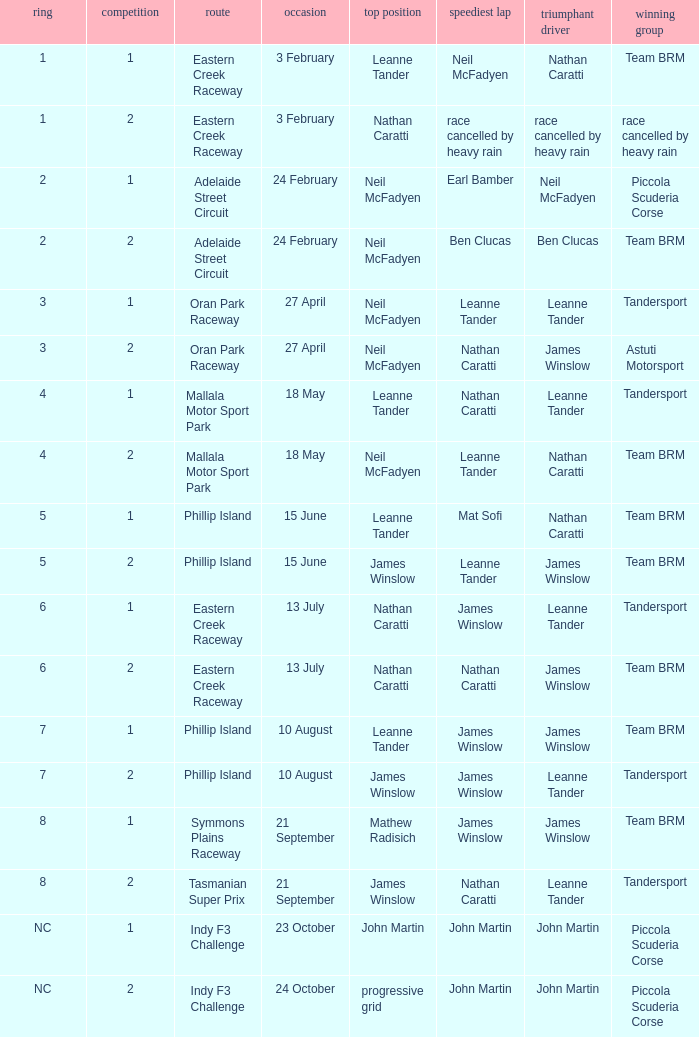What is the highest race number in the Phillip Island circuit with James Winslow as the winning driver and pole position? 2.0. 